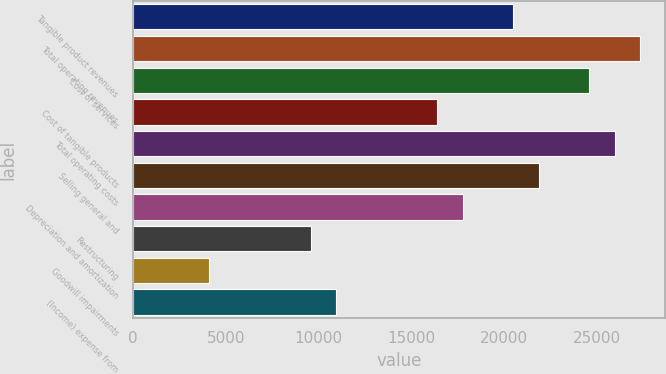Convert chart to OTSL. <chart><loc_0><loc_0><loc_500><loc_500><bar_chart><fcel>Tangible product revenues<fcel>Total operating revenues<fcel>Cost of services<fcel>Cost of tangible products<fcel>Total operating costs<fcel>Selling general and<fcel>Depreciation and amortization<fcel>Restructuring<fcel>Goodwill impairments<fcel>(Income) expense from<nl><fcel>20472.8<fcel>27296.6<fcel>24567.1<fcel>16378.5<fcel>25931.9<fcel>21837.6<fcel>17743.3<fcel>9554.74<fcel>4095.7<fcel>10919.5<nl></chart> 